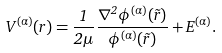<formula> <loc_0><loc_0><loc_500><loc_500>V ^ { ( \alpha ) } ( r ) = \frac { 1 } { 2 \mu } \frac { \nabla ^ { 2 } \phi ^ { ( \alpha ) } ( \vec { r } ) } { \phi ^ { ( \alpha ) } ( \vec { r } ) } + E ^ { ( \alpha ) } .</formula> 